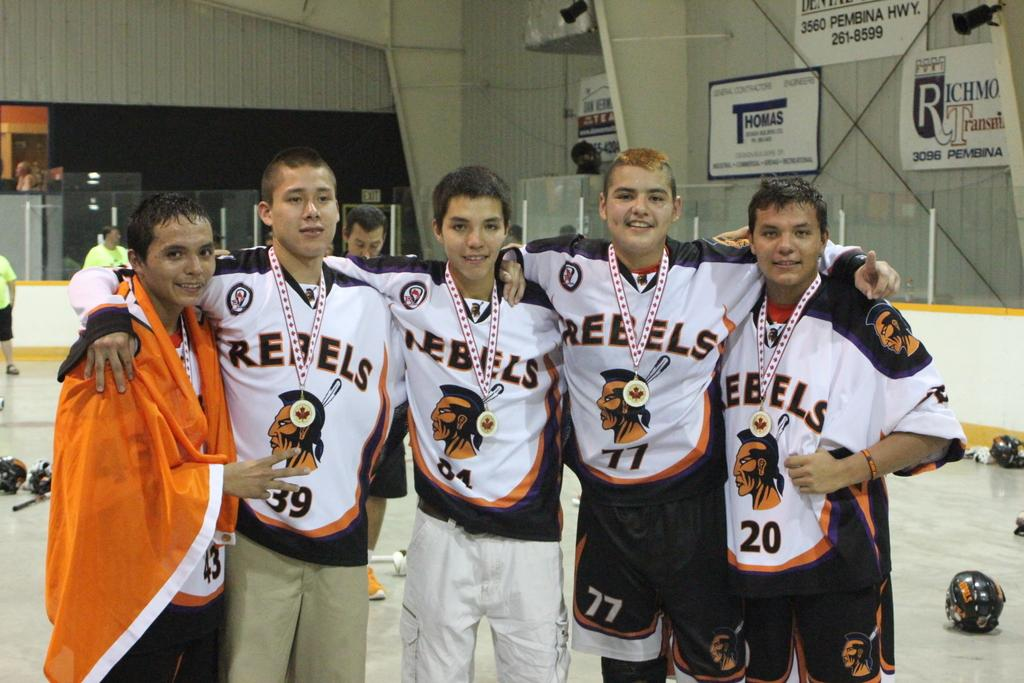Provide a one-sentence caption for the provided image. Five boys posing for on ice wearing jerseys that say Rebels. 